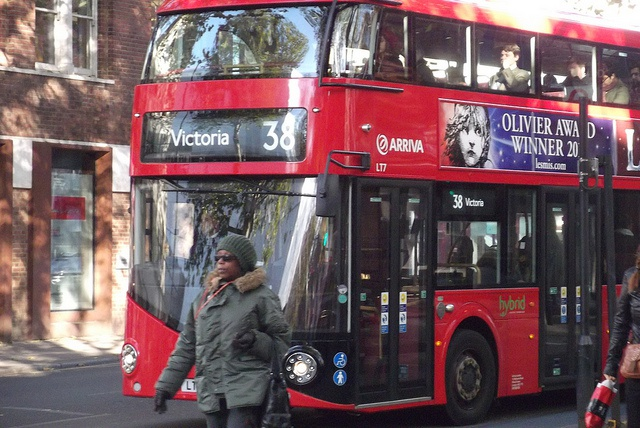Describe the objects in this image and their specific colors. I can see bus in tan, black, gray, darkgray, and white tones, people in tan, gray, and black tones, people in tan, black, gray, maroon, and brown tones, handbag in tan, black, and gray tones, and people in tan, gray, black, and darkgray tones in this image. 